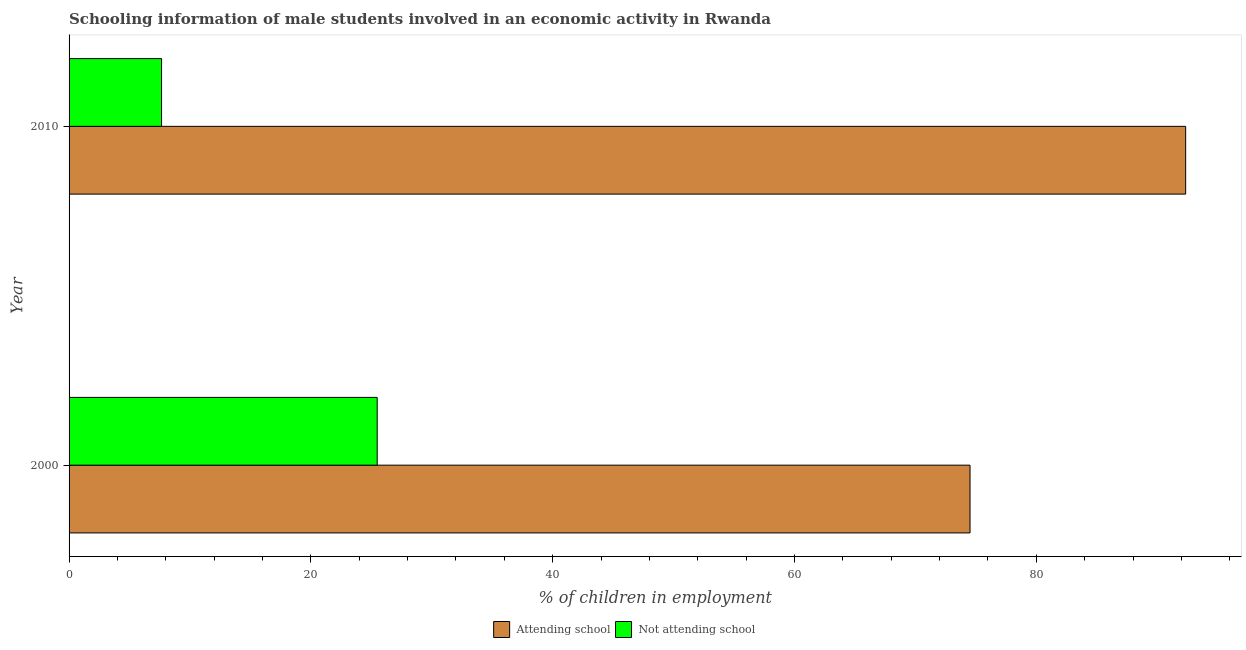How many different coloured bars are there?
Your answer should be compact. 2. Are the number of bars per tick equal to the number of legend labels?
Offer a terse response. Yes. Are the number of bars on each tick of the Y-axis equal?
Your answer should be very brief. Yes. How many bars are there on the 1st tick from the top?
Your answer should be very brief. 2. How many bars are there on the 1st tick from the bottom?
Provide a short and direct response. 2. What is the label of the 1st group of bars from the top?
Provide a short and direct response. 2010. In how many cases, is the number of bars for a given year not equal to the number of legend labels?
Provide a short and direct response. 0. What is the percentage of employed males who are not attending school in 2000?
Your answer should be compact. 25.48. Across all years, what is the maximum percentage of employed males who are attending school?
Ensure brevity in your answer.  92.35. Across all years, what is the minimum percentage of employed males who are attending school?
Your answer should be compact. 74.52. What is the total percentage of employed males who are not attending school in the graph?
Keep it short and to the point. 33.13. What is the difference between the percentage of employed males who are attending school in 2000 and that in 2010?
Your answer should be very brief. -17.84. What is the difference between the percentage of employed males who are not attending school in 2000 and the percentage of employed males who are attending school in 2010?
Your answer should be compact. -66.87. What is the average percentage of employed males who are not attending school per year?
Offer a terse response. 16.57. In the year 2000, what is the difference between the percentage of employed males who are attending school and percentage of employed males who are not attending school?
Keep it short and to the point. 49.03. What is the ratio of the percentage of employed males who are not attending school in 2000 to that in 2010?
Make the answer very short. 3.33. Is the percentage of employed males who are attending school in 2000 less than that in 2010?
Give a very brief answer. Yes. Is the difference between the percentage of employed males who are not attending school in 2000 and 2010 greater than the difference between the percentage of employed males who are attending school in 2000 and 2010?
Your response must be concise. Yes. What does the 2nd bar from the top in 2000 represents?
Make the answer very short. Attending school. What does the 1st bar from the bottom in 2010 represents?
Provide a short and direct response. Attending school. How many bars are there?
Provide a succinct answer. 4. How many years are there in the graph?
Provide a succinct answer. 2. Does the graph contain any zero values?
Your answer should be compact. No. Where does the legend appear in the graph?
Ensure brevity in your answer.  Bottom center. What is the title of the graph?
Your response must be concise. Schooling information of male students involved in an economic activity in Rwanda. What is the label or title of the X-axis?
Give a very brief answer. % of children in employment. What is the label or title of the Y-axis?
Your answer should be compact. Year. What is the % of children in employment of Attending school in 2000?
Your answer should be very brief. 74.52. What is the % of children in employment of Not attending school in 2000?
Give a very brief answer. 25.48. What is the % of children in employment of Attending school in 2010?
Your answer should be very brief. 92.35. What is the % of children in employment in Not attending school in 2010?
Your answer should be compact. 7.65. Across all years, what is the maximum % of children in employment in Attending school?
Give a very brief answer. 92.35. Across all years, what is the maximum % of children in employment in Not attending school?
Offer a terse response. 25.48. Across all years, what is the minimum % of children in employment of Attending school?
Keep it short and to the point. 74.52. Across all years, what is the minimum % of children in employment in Not attending school?
Keep it short and to the point. 7.65. What is the total % of children in employment of Attending school in the graph?
Ensure brevity in your answer.  166.87. What is the total % of children in employment of Not attending school in the graph?
Ensure brevity in your answer.  33.13. What is the difference between the % of children in employment of Attending school in 2000 and that in 2010?
Your answer should be compact. -17.83. What is the difference between the % of children in employment in Not attending school in 2000 and that in 2010?
Provide a succinct answer. 17.83. What is the difference between the % of children in employment in Attending school in 2000 and the % of children in employment in Not attending school in 2010?
Offer a terse response. 66.87. What is the average % of children in employment of Attending school per year?
Provide a succinct answer. 83.43. What is the average % of children in employment of Not attending school per year?
Provide a succinct answer. 16.57. In the year 2000, what is the difference between the % of children in employment in Attending school and % of children in employment in Not attending school?
Provide a succinct answer. 49.03. In the year 2010, what is the difference between the % of children in employment of Attending school and % of children in employment of Not attending school?
Your answer should be very brief. 84.7. What is the ratio of the % of children in employment in Attending school in 2000 to that in 2010?
Ensure brevity in your answer.  0.81. What is the ratio of the % of children in employment in Not attending school in 2000 to that in 2010?
Your answer should be very brief. 3.33. What is the difference between the highest and the second highest % of children in employment in Attending school?
Make the answer very short. 17.83. What is the difference between the highest and the second highest % of children in employment in Not attending school?
Make the answer very short. 17.83. What is the difference between the highest and the lowest % of children in employment of Attending school?
Provide a succinct answer. 17.83. What is the difference between the highest and the lowest % of children in employment of Not attending school?
Keep it short and to the point. 17.83. 